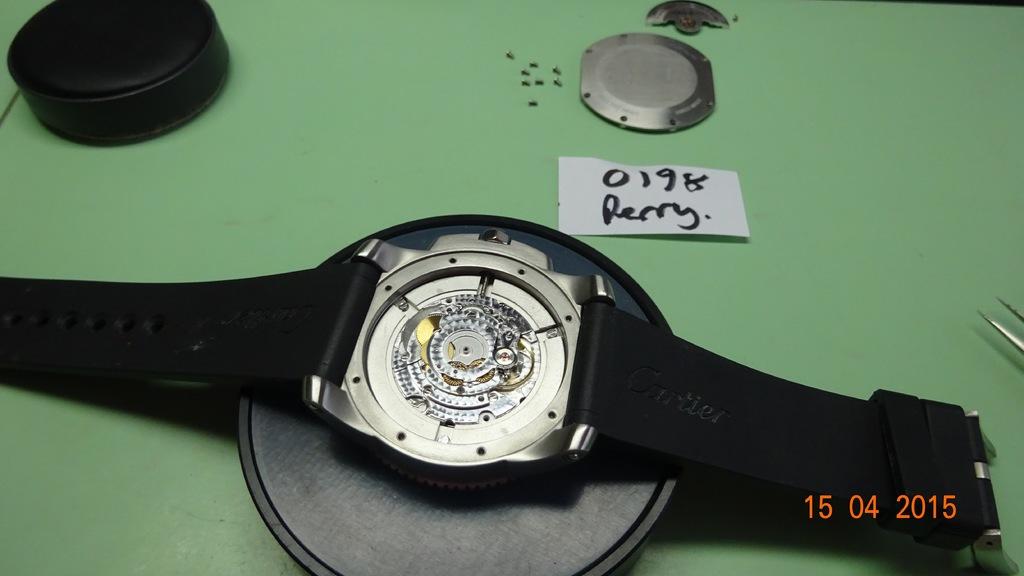What brand is shown on the watch band?
Offer a very short reply. Cartier. 